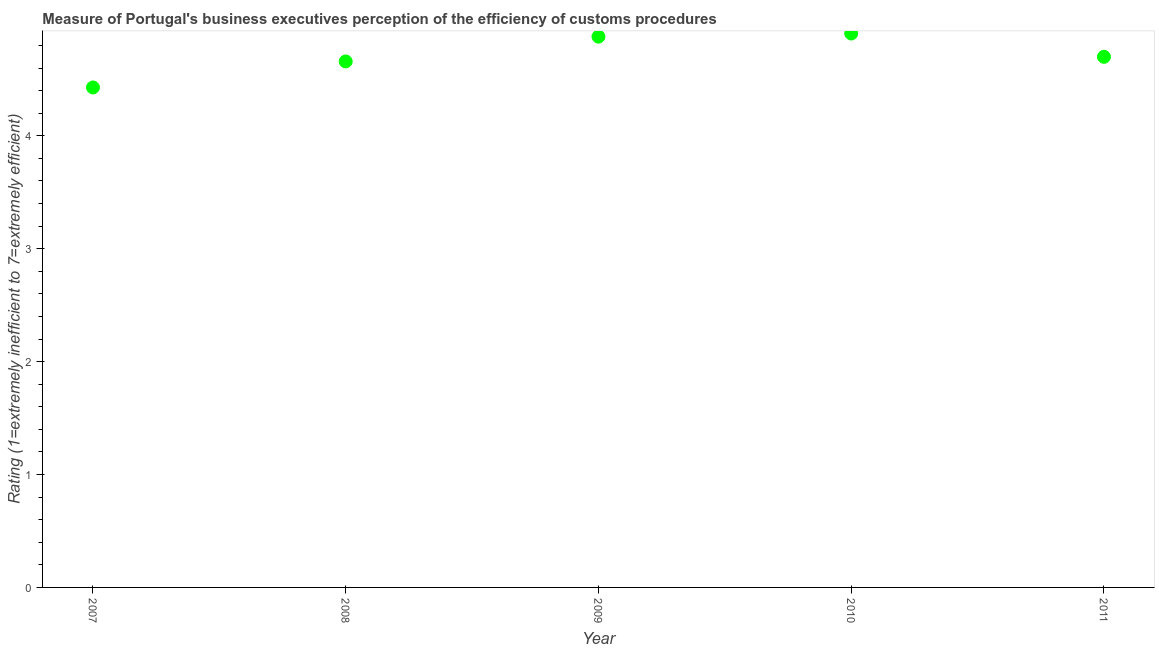What is the rating measuring burden of customs procedure in 2010?
Provide a succinct answer. 4.91. Across all years, what is the maximum rating measuring burden of customs procedure?
Offer a very short reply. 4.91. Across all years, what is the minimum rating measuring burden of customs procedure?
Make the answer very short. 4.43. In which year was the rating measuring burden of customs procedure maximum?
Ensure brevity in your answer.  2010. In which year was the rating measuring burden of customs procedure minimum?
Offer a very short reply. 2007. What is the sum of the rating measuring burden of customs procedure?
Give a very brief answer. 23.57. What is the difference between the rating measuring burden of customs procedure in 2007 and 2010?
Provide a short and direct response. -0.48. What is the average rating measuring burden of customs procedure per year?
Provide a short and direct response. 4.71. In how many years, is the rating measuring burden of customs procedure greater than 2.2 ?
Offer a terse response. 5. Do a majority of the years between 2007 and 2008 (inclusive) have rating measuring burden of customs procedure greater than 4.2 ?
Offer a very short reply. Yes. What is the ratio of the rating measuring burden of customs procedure in 2009 to that in 2010?
Your answer should be very brief. 0.99. What is the difference between the highest and the second highest rating measuring burden of customs procedure?
Give a very brief answer. 0.03. What is the difference between the highest and the lowest rating measuring burden of customs procedure?
Provide a succinct answer. 0.48. In how many years, is the rating measuring burden of customs procedure greater than the average rating measuring burden of customs procedure taken over all years?
Offer a terse response. 2. Does the rating measuring burden of customs procedure monotonically increase over the years?
Ensure brevity in your answer.  No. How many years are there in the graph?
Provide a short and direct response. 5. Are the values on the major ticks of Y-axis written in scientific E-notation?
Keep it short and to the point. No. Does the graph contain any zero values?
Your answer should be very brief. No. What is the title of the graph?
Your answer should be very brief. Measure of Portugal's business executives perception of the efficiency of customs procedures. What is the label or title of the Y-axis?
Give a very brief answer. Rating (1=extremely inefficient to 7=extremely efficient). What is the Rating (1=extremely inefficient to 7=extremely efficient) in 2007?
Your answer should be compact. 4.43. What is the Rating (1=extremely inefficient to 7=extremely efficient) in 2008?
Your answer should be compact. 4.66. What is the Rating (1=extremely inefficient to 7=extremely efficient) in 2009?
Your answer should be compact. 4.88. What is the Rating (1=extremely inefficient to 7=extremely efficient) in 2010?
Offer a terse response. 4.91. What is the difference between the Rating (1=extremely inefficient to 7=extremely efficient) in 2007 and 2008?
Your answer should be very brief. -0.23. What is the difference between the Rating (1=extremely inefficient to 7=extremely efficient) in 2007 and 2009?
Offer a terse response. -0.45. What is the difference between the Rating (1=extremely inefficient to 7=extremely efficient) in 2007 and 2010?
Your response must be concise. -0.48. What is the difference between the Rating (1=extremely inefficient to 7=extremely efficient) in 2007 and 2011?
Provide a succinct answer. -0.27. What is the difference between the Rating (1=extremely inefficient to 7=extremely efficient) in 2008 and 2009?
Provide a short and direct response. -0.22. What is the difference between the Rating (1=extremely inefficient to 7=extremely efficient) in 2008 and 2010?
Your answer should be compact. -0.25. What is the difference between the Rating (1=extremely inefficient to 7=extremely efficient) in 2008 and 2011?
Make the answer very short. -0.04. What is the difference between the Rating (1=extremely inefficient to 7=extremely efficient) in 2009 and 2010?
Give a very brief answer. -0.03. What is the difference between the Rating (1=extremely inefficient to 7=extremely efficient) in 2009 and 2011?
Provide a succinct answer. 0.18. What is the difference between the Rating (1=extremely inefficient to 7=extremely efficient) in 2010 and 2011?
Make the answer very short. 0.21. What is the ratio of the Rating (1=extremely inefficient to 7=extremely efficient) in 2007 to that in 2008?
Provide a succinct answer. 0.95. What is the ratio of the Rating (1=extremely inefficient to 7=extremely efficient) in 2007 to that in 2009?
Make the answer very short. 0.91. What is the ratio of the Rating (1=extremely inefficient to 7=extremely efficient) in 2007 to that in 2010?
Provide a short and direct response. 0.9. What is the ratio of the Rating (1=extremely inefficient to 7=extremely efficient) in 2007 to that in 2011?
Give a very brief answer. 0.94. What is the ratio of the Rating (1=extremely inefficient to 7=extremely efficient) in 2008 to that in 2009?
Offer a terse response. 0.95. What is the ratio of the Rating (1=extremely inefficient to 7=extremely efficient) in 2008 to that in 2010?
Ensure brevity in your answer.  0.95. What is the ratio of the Rating (1=extremely inefficient to 7=extremely efficient) in 2009 to that in 2010?
Your answer should be compact. 0.99. What is the ratio of the Rating (1=extremely inefficient to 7=extremely efficient) in 2009 to that in 2011?
Offer a very short reply. 1.04. What is the ratio of the Rating (1=extremely inefficient to 7=extremely efficient) in 2010 to that in 2011?
Your answer should be very brief. 1.04. 